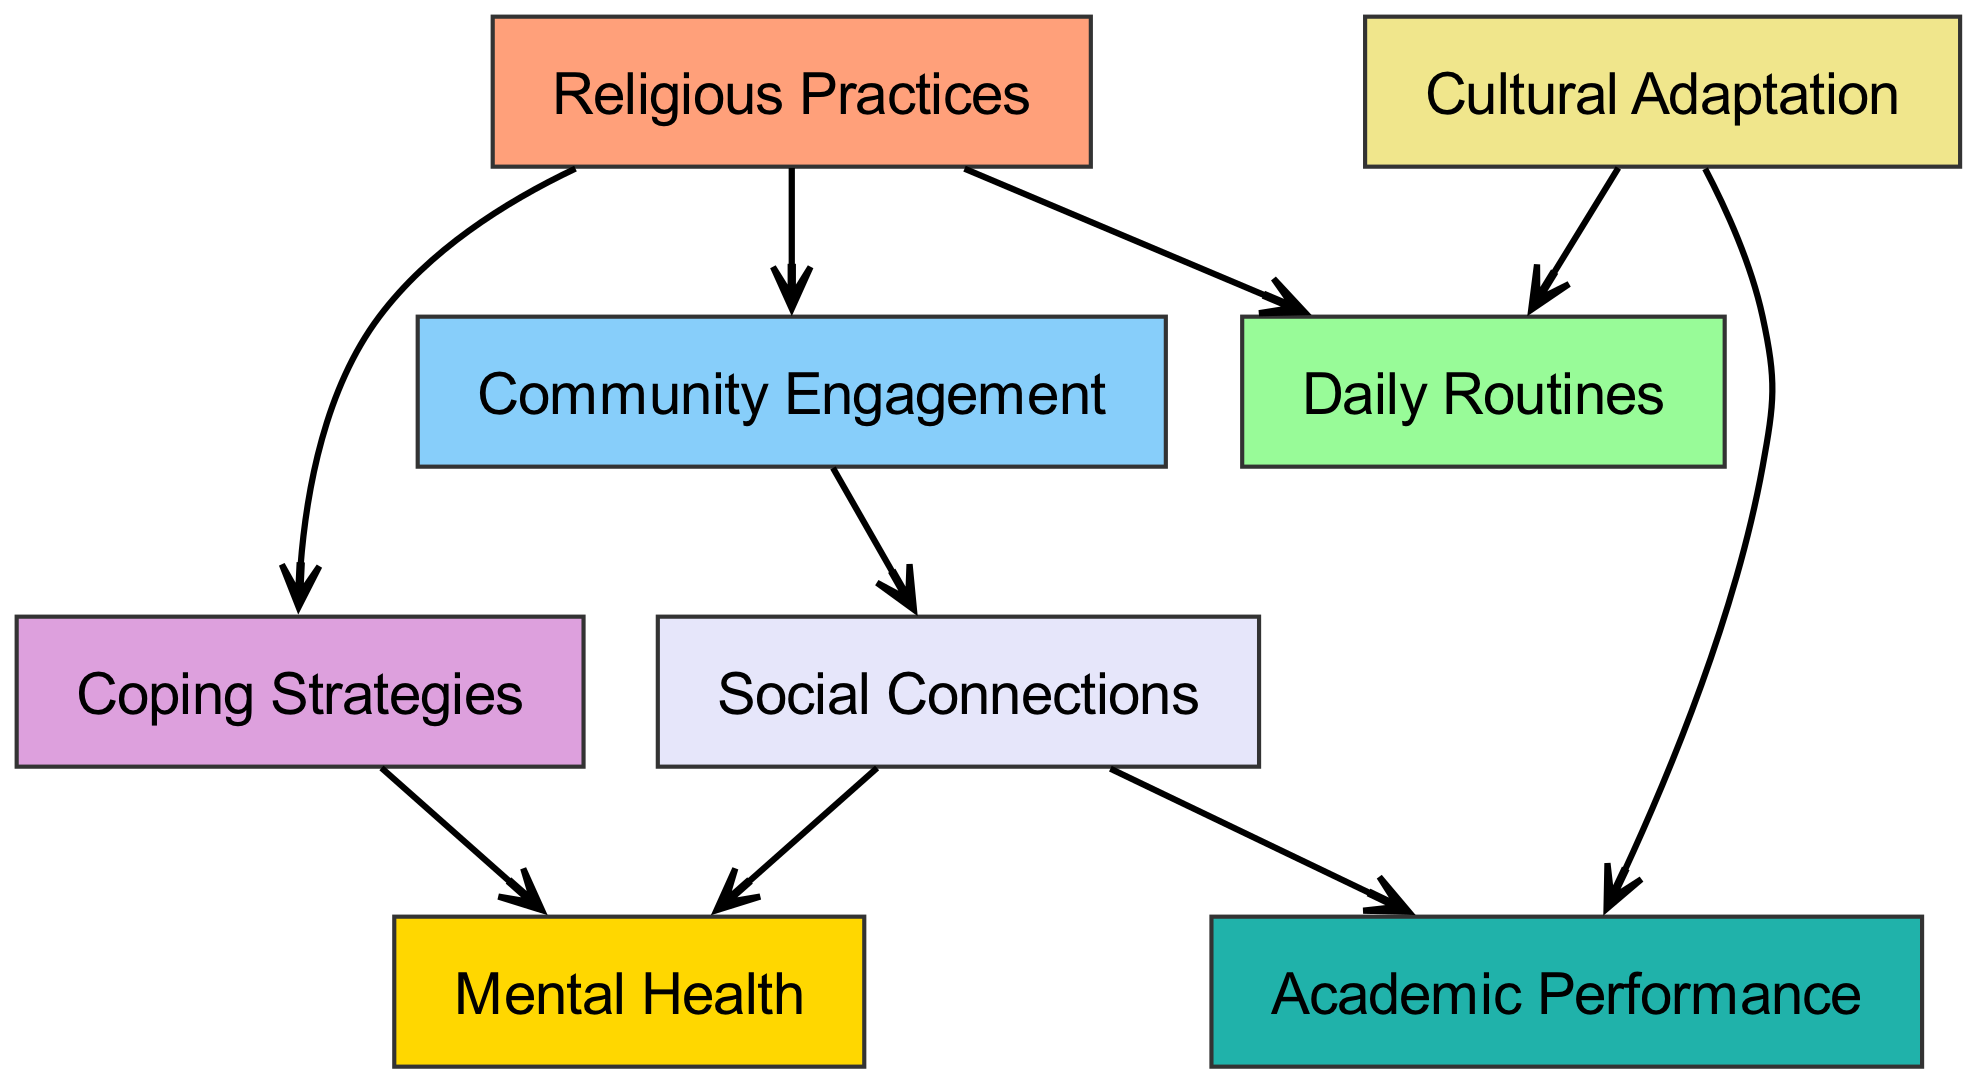What are the main nodes represented in the diagram? The main nodes are directly visible in the diagram and include Religious Practices, Daily Routines, Community Engagement, Coping Strategies, Cultural Adaptation, Social Connections, Mental Health, and Academic Performance.
Answer: Religious Practices, Daily Routines, Community Engagement, Coping Strategies, Cultural Adaptation, Social Connections, Mental Health, Academic Performance How many edges are there in the diagram? By counting the connections drawn between the nodes or edges represented in the diagram, we find that there are eight distinct connections.
Answer: 8 What is the relationship between Religious Practices and Daily Routines? The diagram shows a direct edge pointing from Religious Practices to Daily Routines, indicating that Religious Practices influence or impact Daily Routines.
Answer: Influences Which node is connected to both Coping Strategies and Social Connections? By examining the connections in the diagram, Social Connections is found directly connected to Coping Strategies through an edge, indicating a relationship between these two nodes.
Answer: Social Connections How does Community Engagement affect Social Connections? Community Engagement has a direct edge pointing to Social Connections in the diagram, which means Community Engagement promotes or encourages Social Connections.
Answer: Promotes What is the connection flow from Cultural Adaptation to Academic Performance? The flow begins from Cultural Adaptation with a direct edge to Daily Routines. However, the flow then involves Social Connections, which also connects to Academic Performance, creating an indirect influence through these connections.
Answer: Indirectly connected Which node has the most connections? By analyzing the edges, we can see that the node Social Connections appears to have outgoing connections to both Mental Health and Academic Performance, which contributes to its higher connectivity.
Answer: Social Connections What impact do Coping Strategies have on Mental Health? The diagram shows a direct edge from Coping Strategies to Mental Health, indicating that Coping Strategies have a positive or significant influence on Mental Health.
Answer: Positive influence 